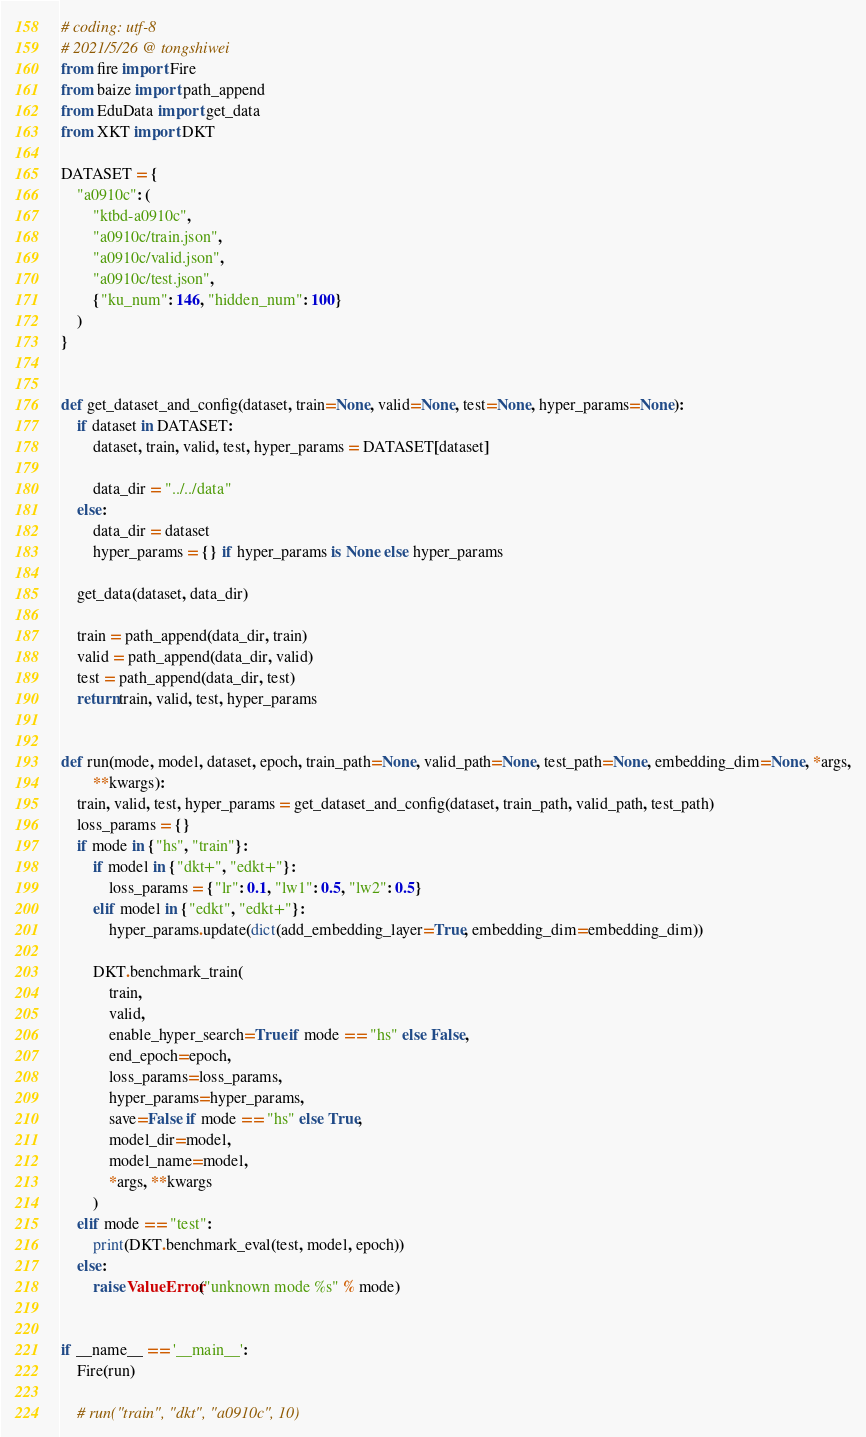Convert code to text. <code><loc_0><loc_0><loc_500><loc_500><_Python_># coding: utf-8
# 2021/5/26 @ tongshiwei
from fire import Fire
from baize import path_append
from EduData import get_data
from XKT import DKT

DATASET = {
    "a0910c": (
        "ktbd-a0910c",
        "a0910c/train.json",
        "a0910c/valid.json",
        "a0910c/test.json",
        {"ku_num": 146, "hidden_num": 100}
    )
}


def get_dataset_and_config(dataset, train=None, valid=None, test=None, hyper_params=None):
    if dataset in DATASET:
        dataset, train, valid, test, hyper_params = DATASET[dataset]

        data_dir = "../../data"
    else:
        data_dir = dataset
        hyper_params = {} if hyper_params is None else hyper_params

    get_data(dataset, data_dir)

    train = path_append(data_dir, train)
    valid = path_append(data_dir, valid)
    test = path_append(data_dir, test)
    return train, valid, test, hyper_params


def run(mode, model, dataset, epoch, train_path=None, valid_path=None, test_path=None, embedding_dim=None, *args,
        **kwargs):
    train, valid, test, hyper_params = get_dataset_and_config(dataset, train_path, valid_path, test_path)
    loss_params = {}
    if mode in {"hs", "train"}:
        if model in {"dkt+", "edkt+"}:
            loss_params = {"lr": 0.1, "lw1": 0.5, "lw2": 0.5}
        elif model in {"edkt", "edkt+"}:
            hyper_params.update(dict(add_embedding_layer=True, embedding_dim=embedding_dim))

        DKT.benchmark_train(
            train,
            valid,
            enable_hyper_search=True if mode == "hs" else False,
            end_epoch=epoch,
            loss_params=loss_params,
            hyper_params=hyper_params,
            save=False if mode == "hs" else True,
            model_dir=model,
            model_name=model,
            *args, **kwargs
        )
    elif mode == "test":
        print(DKT.benchmark_eval(test, model, epoch))
    else:
        raise ValueError("unknown mode %s" % mode)


if __name__ == '__main__':
    Fire(run)

    # run("train", "dkt", "a0910c", 10)
</code> 